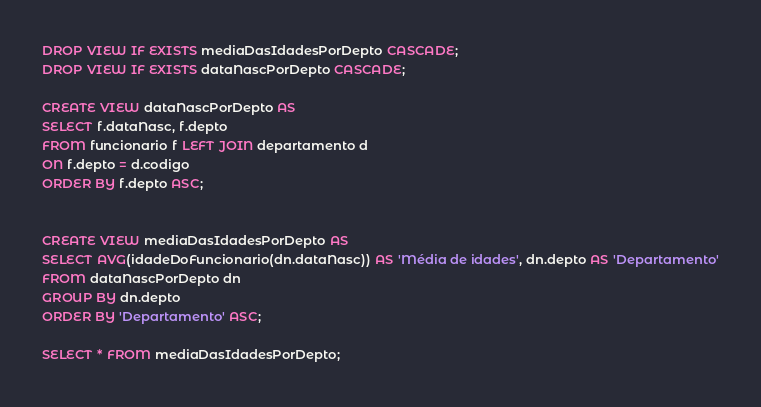<code> <loc_0><loc_0><loc_500><loc_500><_SQL_>DROP VIEW IF EXISTS mediaDasIdadesPorDepto CASCADE;
DROP VIEW IF EXISTS dataNascPorDepto CASCADE;

CREATE VIEW dataNascPorDepto AS
SELECT f.dataNasc, f.depto
FROM funcionario f LEFT JOIN departamento d
ON f.depto = d.codigo
ORDER BY f.depto ASC;


CREATE VIEW mediaDasIdadesPorDepto AS
SELECT AVG(idadeDoFuncionario(dn.dataNasc)) AS 'Média de idades', dn.depto AS 'Departamento'
FROM dataNascPorDepto dn
GROUP BY dn.depto
ORDER BY 'Departamento' ASC;

SELECT * FROM mediaDasIdadesPorDepto;</code> 